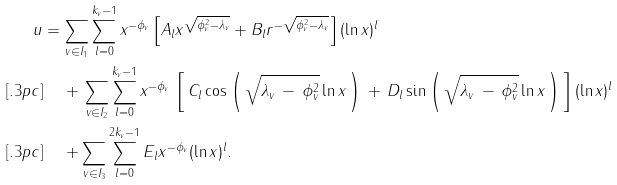Convert formula to latex. <formula><loc_0><loc_0><loc_500><loc_500>u & = \sum _ { v \in I _ { 1 } } \sum _ { l = 0 } ^ { k _ { v } - 1 } x ^ { - \phi _ { v } } \left [ A _ { l } x ^ { \sqrt { \phi _ { v } ^ { 2 } - \lambda _ { v } } } + B _ { l } r ^ { - \sqrt { \phi _ { v } ^ { 2 } - \lambda _ { v } } } \right ] ( \ln x ) ^ { l } \\ [ . 3 p c ] & \quad \, + \, \sum _ { v \in I _ { 2 } } \sum _ { l = 0 } ^ { k _ { v } - 1 } x ^ { - \phi _ { v } } \, \left [ \, C _ { l } \cos \left ( \, \sqrt { \lambda _ { v } \, - \, \phi _ { v } ^ { 2 } } \ln x \, \right ) \, + \, D _ { l } \sin \left ( \, \sqrt { \lambda _ { v } \, - \, \phi _ { v } ^ { 2 } } \ln x \, \right ) \, \right ] ( \ln x ) ^ { l } \\ [ . 3 p c ] & \quad \, + \sum _ { v \in I _ { 3 } } \sum _ { l = 0 } ^ { 2 k _ { v } - 1 } E _ { l } x ^ { - \phi _ { v } } ( \ln x ) ^ { l } .</formula> 